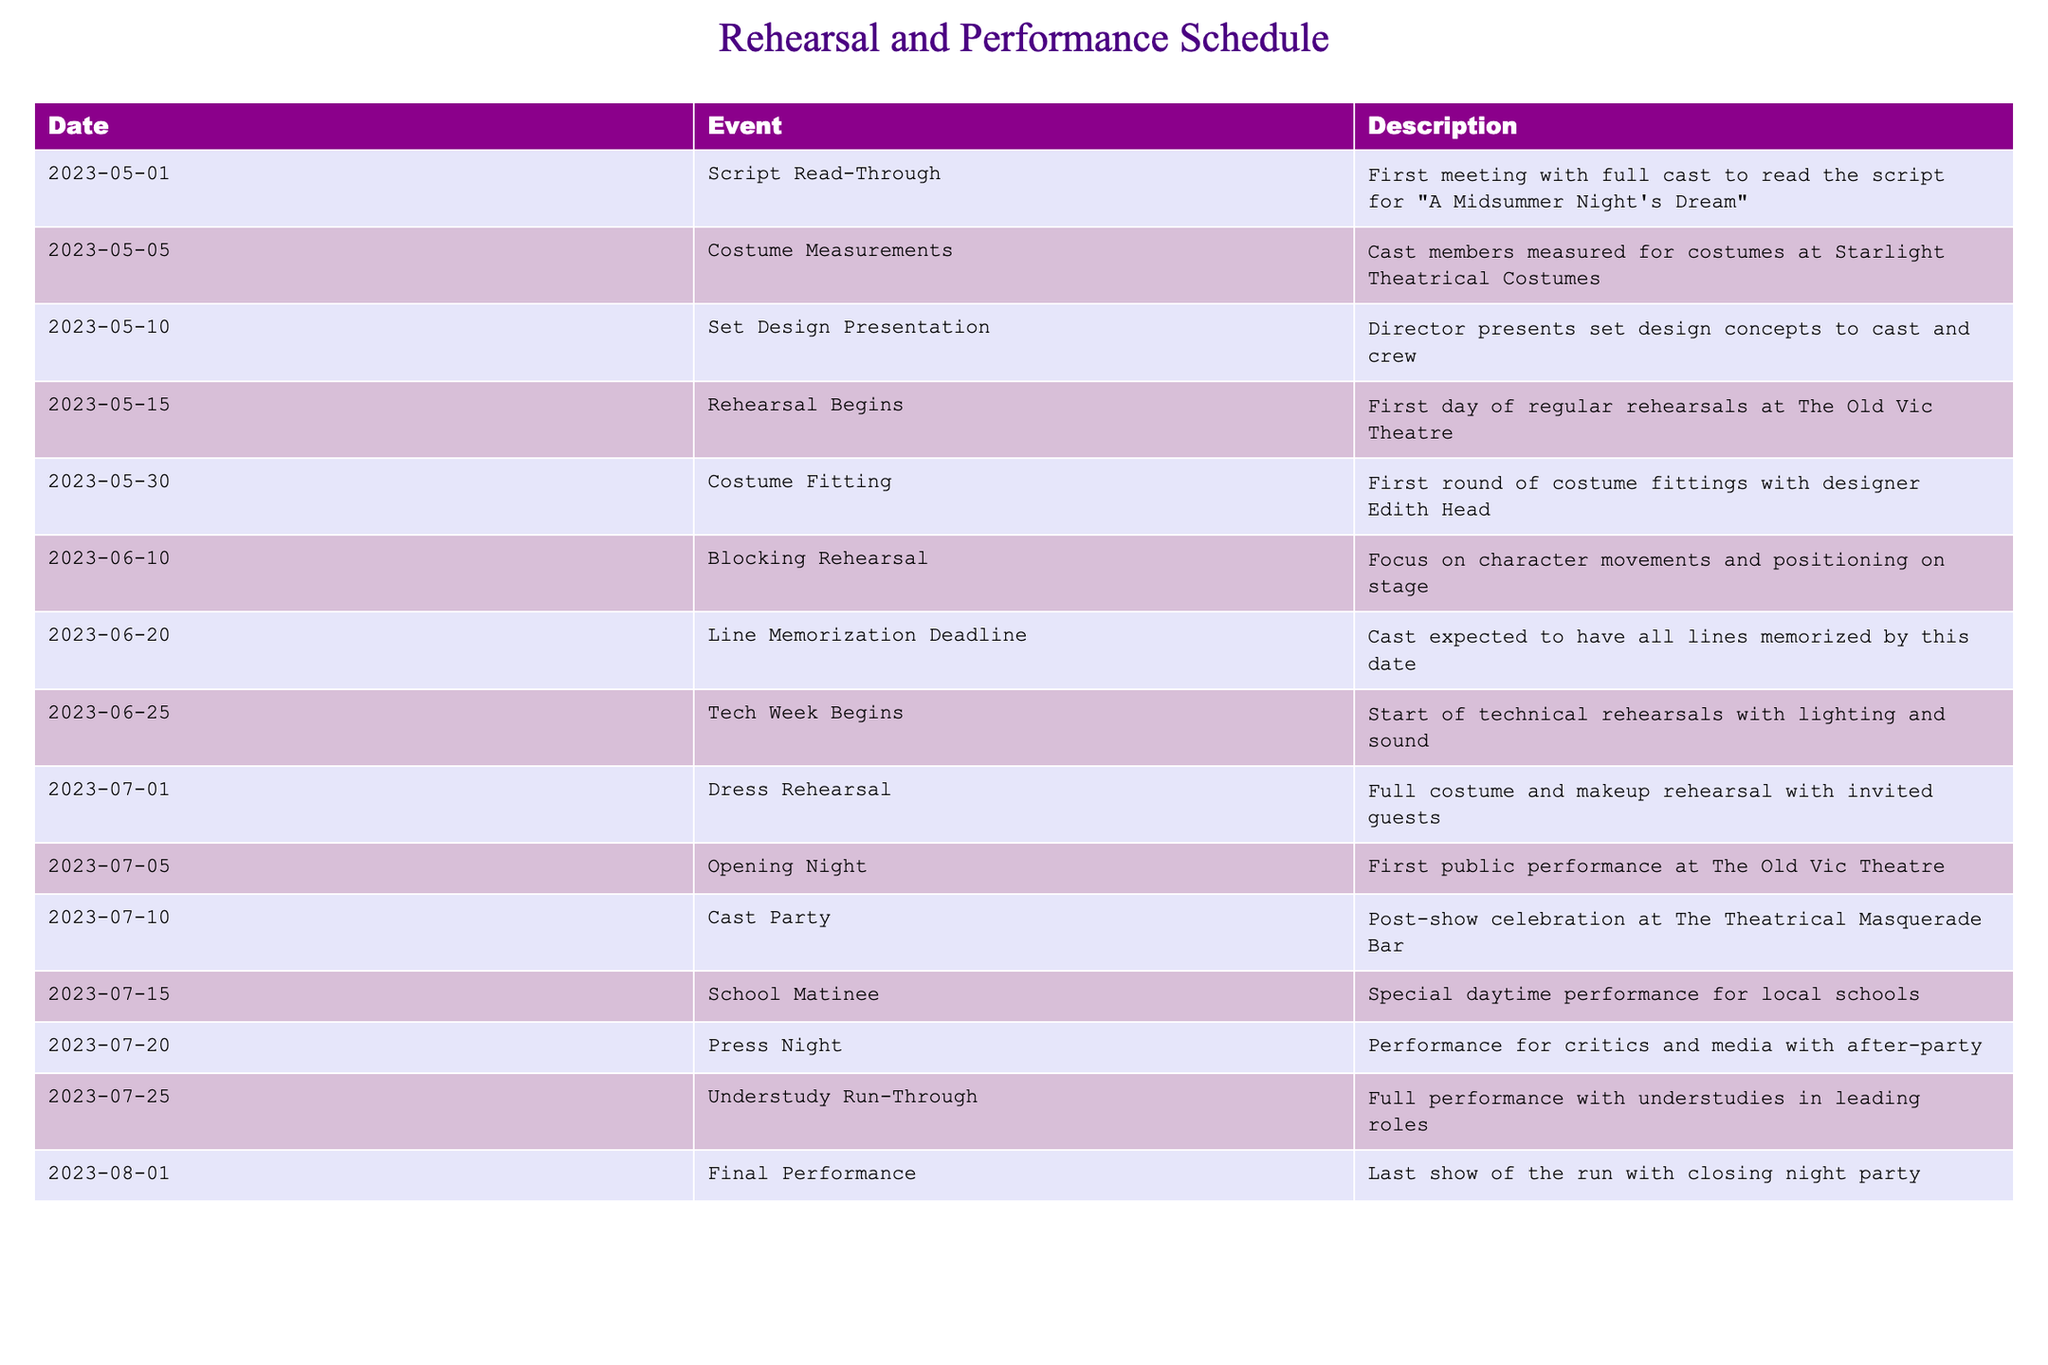What date does the Dress Rehearsal take place? According to the table, the Dress Rehearsal is scheduled for July 1, 2023. This information is directly listed under the Date column corresponding to the Dress Rehearsal event.
Answer: July 1, 2023 What is the main event happening on June 25, 2023? The event listed for June 25, 2023, is the beginning of Tech Week, which involves technical rehearsals focusing on lighting and sound. This can be found directly in the Event and Description columns corresponding to that date.
Answer: Tech Week Begins How many days are there between the Opening Night and the Final Performance? The Opening Night is on July 5, 2023, and the Final Performance is on August 1, 2023. Calculating the interval, there are 27 days from July 5 to August 1.
Answer: 27 days Is there a performance for local schools in this schedule? Yes, there is a School Matinee scheduled for July 15, 2023, which is specifically described as a special daytime performance for local schools. This is confirmed by referencing the Event column for that date.
Answer: Yes What events occur in June, and how many are they? In June, there are three events: Line Memorization Deadline on June 20, Tech Week Begins on June 25, and Blocking Rehearsal on June 10. Therefore, there are three events total in June, confirmed by counting the relevant entries in the Date column for that month.
Answer: 3 events What is the time span between the first rehearsal and the dress rehearsal? The first rehearsal starts on May 15, 2023, and the dress rehearsal takes place on July 1, 2023. To calculate the span, we can count the days: from May 15 to July 1 is 47 days, which involves summing the days in May (16 days remaining) and June (30 days).
Answer: 47 days Are there any costume-related events before the Tech Week? Yes, there are two costume-related events before Tech Week: Costume Measurements on May 5, and Costume Fitting on May 30. This conclusion comes from checking the Event column for any mention of costume activities that precede the specified date of June 25 for Tech Week.
Answer: Yes How many total performances are scheduled after the Opening Night? After the Opening Night on July 5, there are four performances scheduled: School Matinee on July 15, Press Night on July 20, Understudy Run-Through on July 25, and the Final Performance on August 1. This is determined by counting all the listed performances that occur after July 5.
Answer: 4 performances 